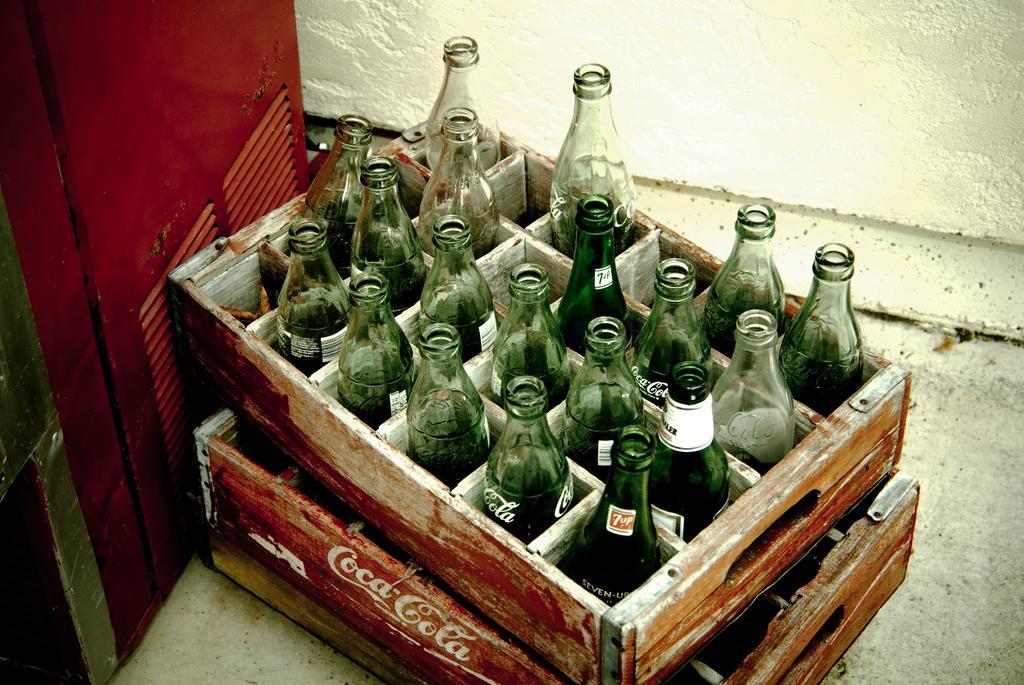In one or two sentences, can you explain what this image depicts? In this image i can see few bottles kept in a tray. At the background i can see a fridge and a wall. 